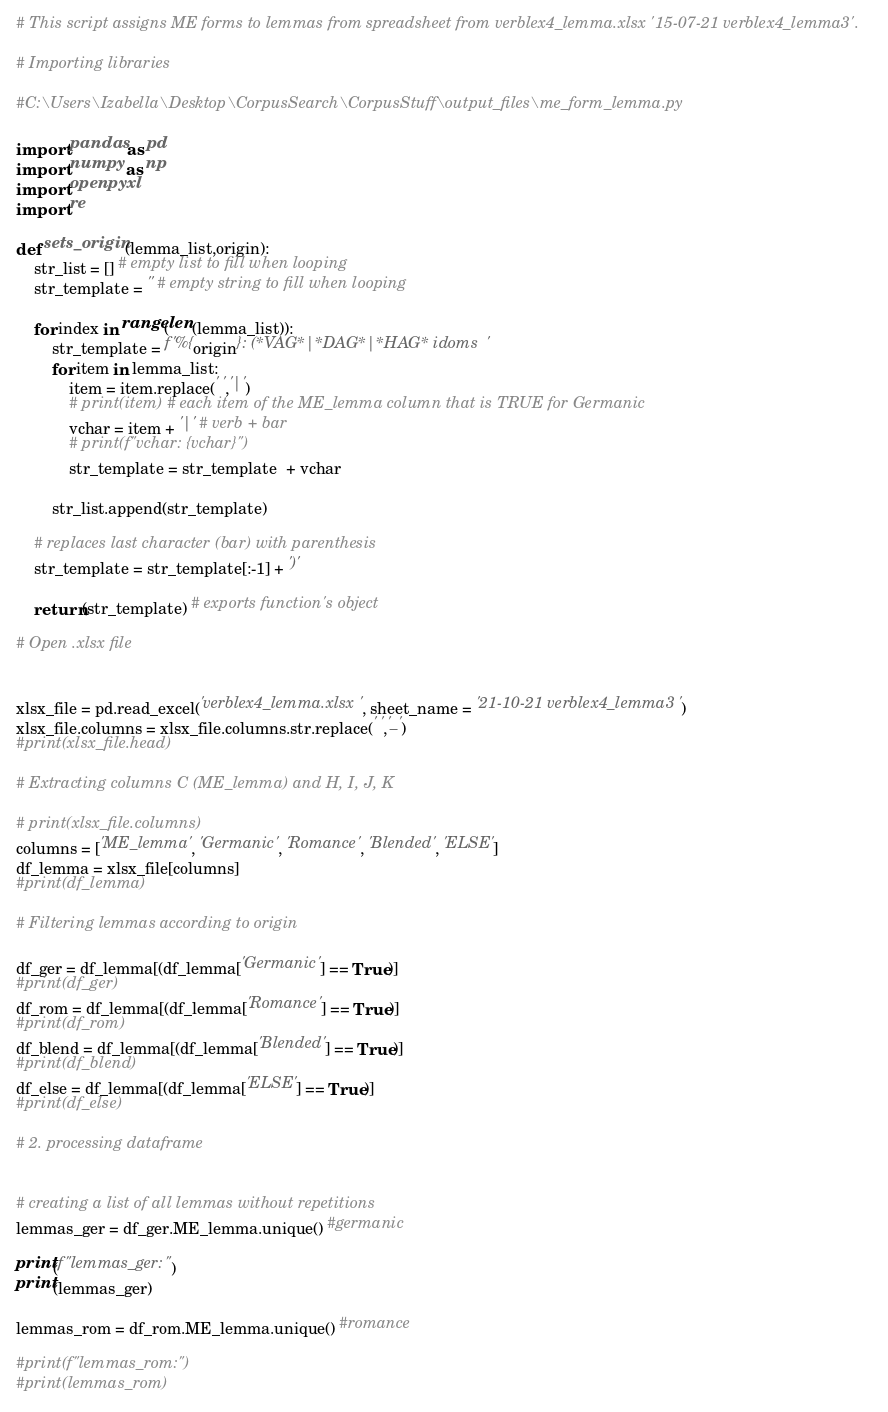Convert code to text. <code><loc_0><loc_0><loc_500><loc_500><_Python_># This script assigns ME forms to lemmas from spreadsheet from verblex4_lemma.xlsx '15-07-21 verblex4_lemma3'.

# Importing libraries

#C:\Users\Izabella\Desktop\CorpusSearch\CorpusStuff\output_files\me_form_lemma.py

import pandas as pd
import numpy as np
import openpyxl
import re

def sets_origin(lemma_list,origin):
    str_list = [] # empty list to fill when looping
    str_template = '' # empty string to fill when looping

    for index in range(len(lemma_list)):
        str_template = f'%{origin}: (*VAG*|*DAG*|*HAG* idoms '
        for item in lemma_list:
            item = item.replace(' ','|')
            # print(item) # each item of the ME_lemma column that is TRUE for Germanic 
            vchar = item + '|' # verb + bar
            # print(f"vchar: {vchar}")
            str_template = str_template  + vchar

        str_list.append(str_template)

    # replaces last character (bar) with parenthesis
    str_template = str_template[:-1] + ')'

    return(str_template) # exports function's object

# Open .xlsx file


xlsx_file = pd.read_excel('verblex4_lemma.xlsx', sheet_name = '21-10-21 verblex4_lemma3')
xlsx_file.columns = xlsx_file.columns.str.replace(' ','_')
#print(xlsx_file.head)

# Extracting columns C (ME_lemma) and H, I, J, K

# print(xlsx_file.columns)
columns = ['ME_lemma', 'Germanic', 'Romance', 'Blended', 'ELSE']
df_lemma = xlsx_file[columns]
#print(df_lemma)

# Filtering lemmas according to origin

df_ger = df_lemma[(df_lemma['Germanic'] == True)]
#print(df_ger)
df_rom = df_lemma[(df_lemma['Romance'] == True)]
#print(df_rom)
df_blend = df_lemma[(df_lemma['Blended'] == True)]
#print(df_blend)
df_else = df_lemma[(df_lemma['ELSE'] == True)]
#print(df_else)

# 2. processing dataframe


# creating a list of all lemmas without repetitions
lemmas_ger = df_ger.ME_lemma.unique() #germanic

print(f"lemmas_ger:")
print(lemmas_ger)

lemmas_rom = df_rom.ME_lemma.unique() #romance

#print(f"lemmas_rom:")
#print(lemmas_rom)
</code> 